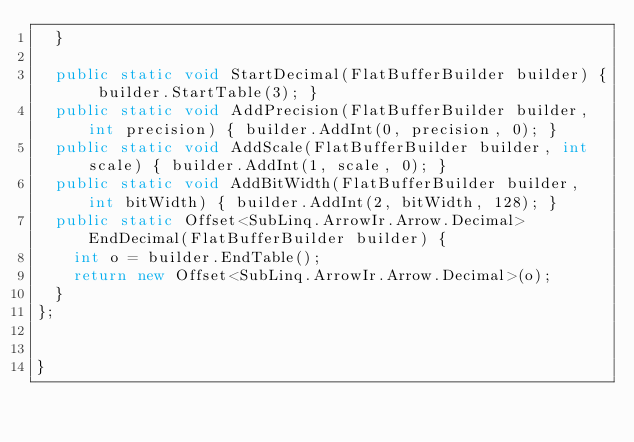Convert code to text. <code><loc_0><loc_0><loc_500><loc_500><_C#_>  }

  public static void StartDecimal(FlatBufferBuilder builder) { builder.StartTable(3); }
  public static void AddPrecision(FlatBufferBuilder builder, int precision) { builder.AddInt(0, precision, 0); }
  public static void AddScale(FlatBufferBuilder builder, int scale) { builder.AddInt(1, scale, 0); }
  public static void AddBitWidth(FlatBufferBuilder builder, int bitWidth) { builder.AddInt(2, bitWidth, 128); }
  public static Offset<SubLinq.ArrowIr.Arrow.Decimal> EndDecimal(FlatBufferBuilder builder) {
    int o = builder.EndTable();
    return new Offset<SubLinq.ArrowIr.Arrow.Decimal>(o);
  }
};


}
</code> 